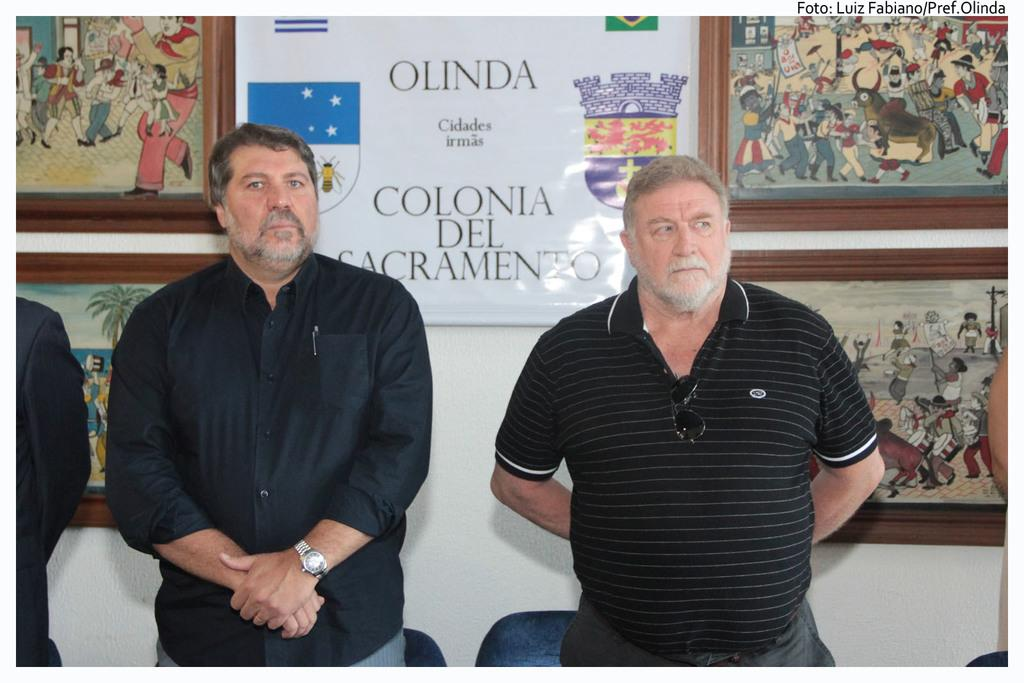How many people are in the image? There are two persons standing in the image. What are the persons wearing? The persons are wearing black dress. What furniture can be seen in the image? There are chairs in the image. What is visible in the background of the image? There is a wall in the background of the image. What decorations are on the wall? There are photo frames on the wall. What type of rose is being used as a centerpiece on the table in the image? There is no rose or table present in the image. 